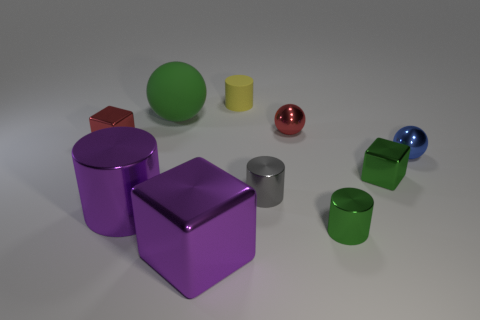Subtract all balls. How many objects are left? 7 Subtract all small gray things. Subtract all shiny cylinders. How many objects are left? 6 Add 4 matte balls. How many matte balls are left? 5 Add 8 red metal balls. How many red metal balls exist? 9 Subtract all yellow cylinders. How many cylinders are left? 3 Subtract all tiny green cylinders. How many cylinders are left? 3 Subtract 0 purple balls. How many objects are left? 10 Subtract 2 cubes. How many cubes are left? 1 Subtract all purple balls. Subtract all blue cylinders. How many balls are left? 3 Subtract all red spheres. How many purple blocks are left? 1 